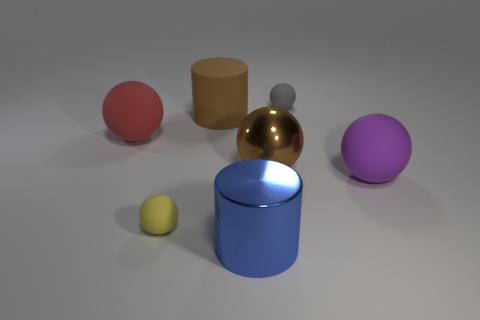Are there any brown rubber cylinders that have the same size as the purple matte ball?
Keep it short and to the point. Yes. There is a red ball that is in front of the gray rubber ball; is there a brown thing behind it?
Your answer should be compact. Yes. What number of balls are blue metal objects or tiny gray matte things?
Offer a terse response. 1. Is there a red object of the same shape as the purple rubber thing?
Offer a terse response. Yes. The yellow rubber object has what shape?
Offer a very short reply. Sphere. What number of things are tiny blocks or blue shiny cylinders?
Ensure brevity in your answer.  1. There is a blue cylinder that is in front of the metal ball; does it have the same size as the thing that is to the right of the small gray thing?
Offer a very short reply. Yes. How many other objects are the same material as the red object?
Your answer should be compact. 4. Are there more big brown cylinders that are on the left side of the red thing than shiny cylinders on the left side of the large brown rubber object?
Offer a terse response. No. There is a ball in front of the big purple sphere; what is its material?
Make the answer very short. Rubber. 